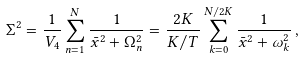Convert formula to latex. <formula><loc_0><loc_0><loc_500><loc_500>\Sigma ^ { 2 } = \frac { 1 } { V _ { 4 } } \sum _ { n = 1 } ^ { N } \frac { 1 } { { \bar { x } } ^ { 2 } + \Omega _ { n } ^ { 2 } } = \frac { 2 K } { K / T } \sum _ { k = 0 } ^ { N / 2 K } \frac { 1 } { { \bar { x } } ^ { 2 } + \omega _ { k } ^ { 2 } } \, ,</formula> 